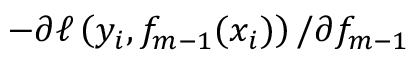<formula> <loc_0><loc_0><loc_500><loc_500>- \partial \ell \left ( y _ { i } , f _ { m - 1 } ( x _ { i } ) \right ) / \partial f _ { m - 1 }</formula> 